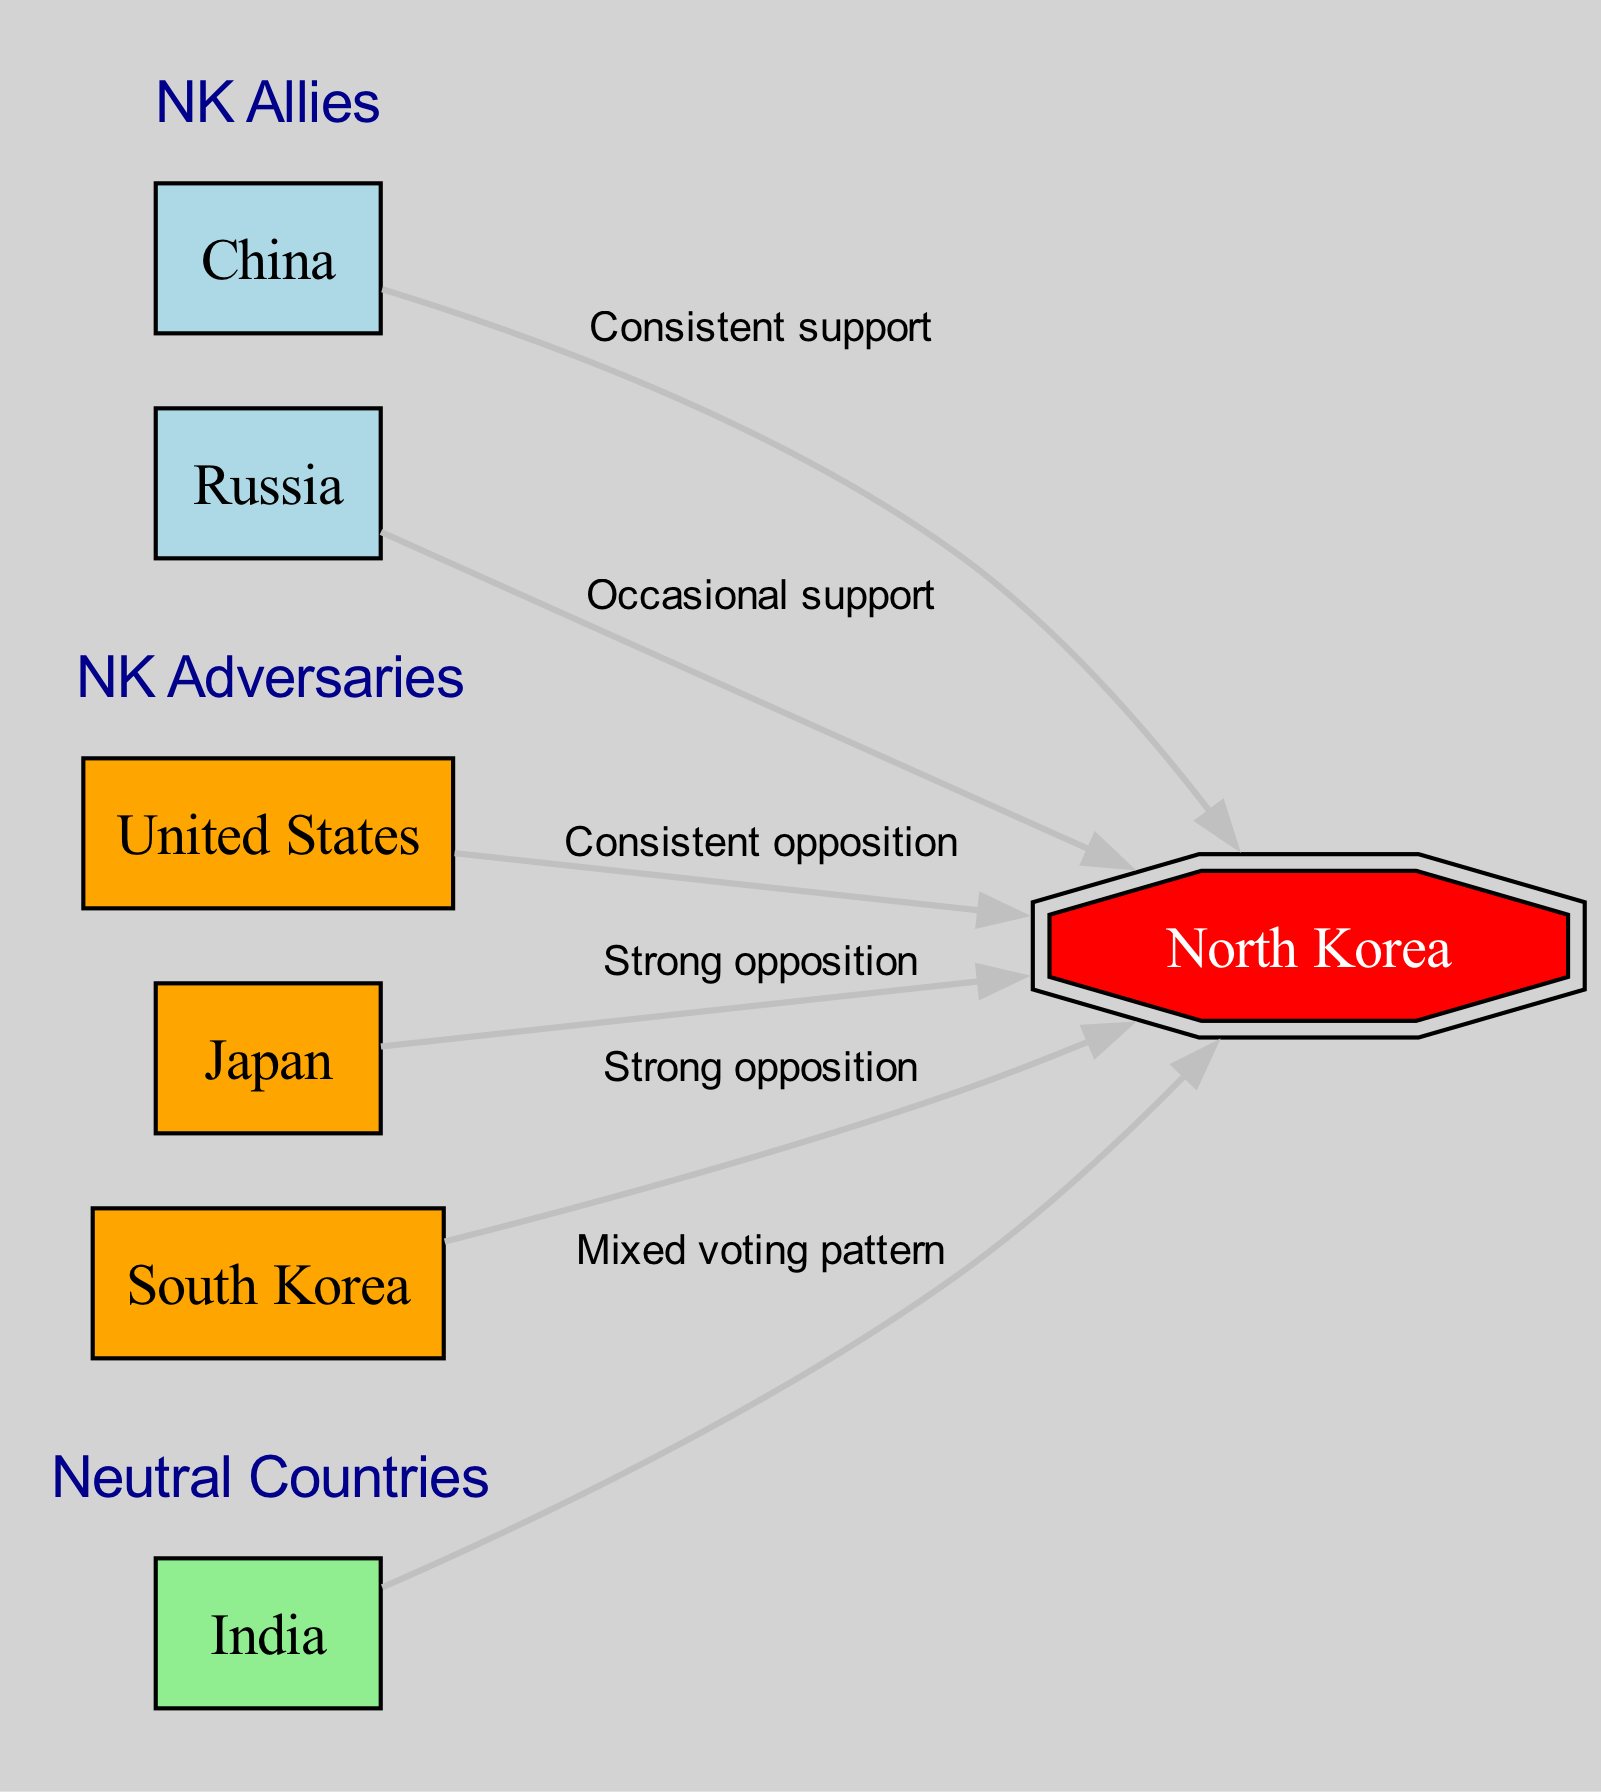What is the label of the focus country node? The focus country node in the diagram represents North Korea, which is labeled as "North Korea."
Answer: North Korea How many allies does North Korea have? By examining the ally cluster, we can see that North Korea has two allies: China and Russia.
Answer: 2 What type of relationship does the United States have with North Korea? The edge connecting the United States to North Korea is labeled "Consistent opposition," indicating that it is an adversarial relationship.
Answer: Consistent opposition Which country shows occasional support for North Korea? Looking at the edges, Russia is indicated to provide "Occasional support" to North Korea.
Answer: Russia How many neutral countries are represented in the diagram? The neutral cluster only includes one country, which is India.
Answer: 1 What color represents adversaries in the diagram? The adversaries are depicted using an orange box, which visually distinguishes them from allies and the neutral countries.
Answer: Orange Which country has a mixed voting pattern with respect to North Korea? The edge shows that India has a "Mixed voting pattern" towards North Korea, indicating it does not consistently support or oppose.
Answer: India What is the connection type between Japan and North Korea? The edge indicates a "Strong opposition" relationship between Japan and North Korea, signifying that Japan consistently opposes North Korea's actions.
Answer: Strong opposition How many edges are connected to the North Korea node? By counting the edges that originate from North Korea, we see a total of six connections; two for allies, three for adversaries, and one for neutral countries.
Answer: 6 